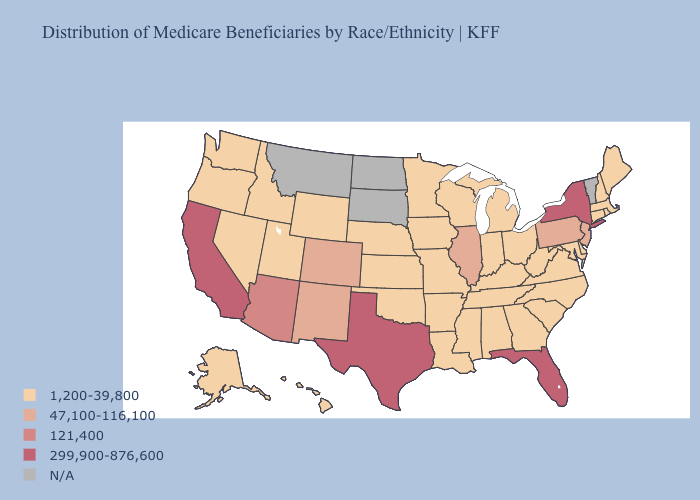Does the map have missing data?
Concise answer only. Yes. What is the value of Oregon?
Give a very brief answer. 1,200-39,800. Which states hav the highest value in the South?
Answer briefly. Florida, Texas. What is the lowest value in states that border Utah?
Keep it brief. 1,200-39,800. Does the first symbol in the legend represent the smallest category?
Give a very brief answer. Yes. Name the states that have a value in the range 1,200-39,800?
Quick response, please. Alabama, Alaska, Arkansas, Connecticut, Delaware, Georgia, Hawaii, Idaho, Indiana, Iowa, Kansas, Kentucky, Louisiana, Maine, Maryland, Massachusetts, Michigan, Minnesota, Mississippi, Missouri, Nebraska, Nevada, New Hampshire, North Carolina, Ohio, Oklahoma, Oregon, Rhode Island, South Carolina, Tennessee, Utah, Virginia, Washington, West Virginia, Wisconsin, Wyoming. Among the states that border California , does Arizona have the highest value?
Be succinct. Yes. Name the states that have a value in the range 47,100-116,100?
Quick response, please. Colorado, Illinois, New Jersey, New Mexico, Pennsylvania. Which states have the highest value in the USA?
Give a very brief answer. California, Florida, New York, Texas. What is the value of Hawaii?
Be succinct. 1,200-39,800. Name the states that have a value in the range 47,100-116,100?
Short answer required. Colorado, Illinois, New Jersey, New Mexico, Pennsylvania. Which states have the lowest value in the USA?
Be succinct. Alabama, Alaska, Arkansas, Connecticut, Delaware, Georgia, Hawaii, Idaho, Indiana, Iowa, Kansas, Kentucky, Louisiana, Maine, Maryland, Massachusetts, Michigan, Minnesota, Mississippi, Missouri, Nebraska, Nevada, New Hampshire, North Carolina, Ohio, Oklahoma, Oregon, Rhode Island, South Carolina, Tennessee, Utah, Virginia, Washington, West Virginia, Wisconsin, Wyoming. Name the states that have a value in the range 47,100-116,100?
Answer briefly. Colorado, Illinois, New Jersey, New Mexico, Pennsylvania. What is the value of Colorado?
Keep it brief. 47,100-116,100. Does West Virginia have the highest value in the USA?
Quick response, please. No. 